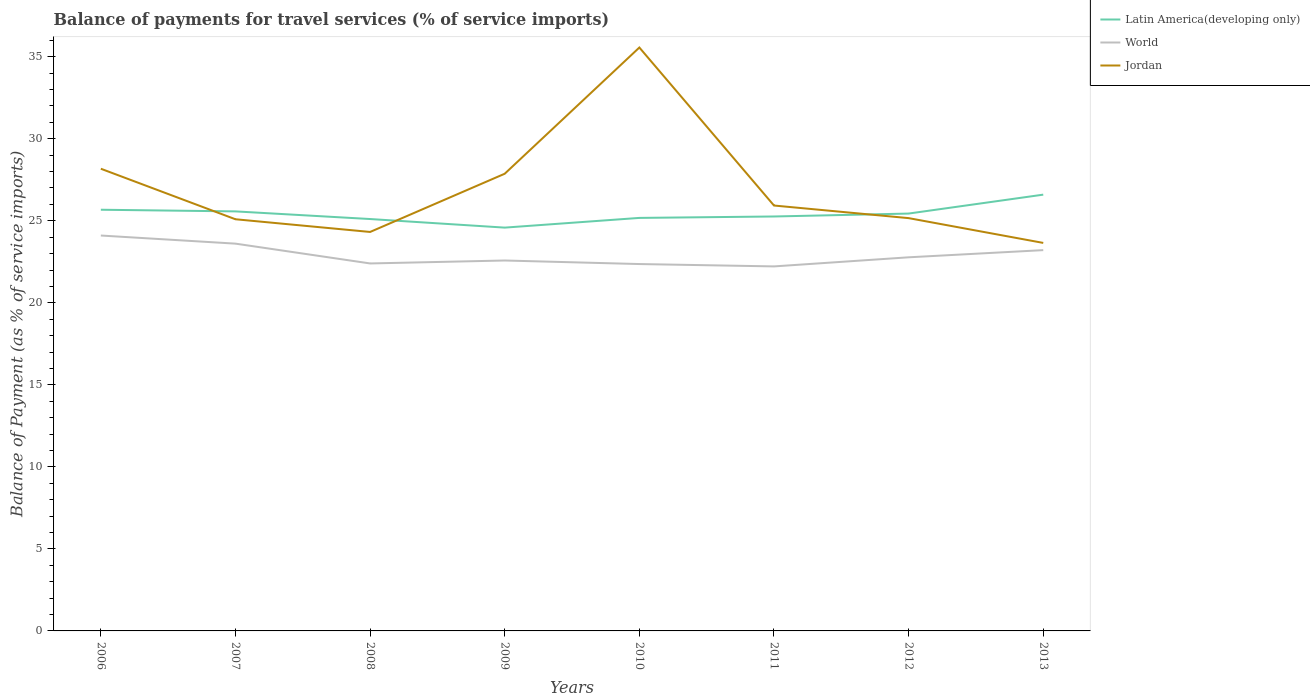How many different coloured lines are there?
Offer a terse response. 3. Across all years, what is the maximum balance of payments for travel services in Jordan?
Make the answer very short. 23.65. What is the total balance of payments for travel services in Jordan in the graph?
Ensure brevity in your answer.  2.28. What is the difference between the highest and the second highest balance of payments for travel services in Jordan?
Your response must be concise. 11.91. Is the balance of payments for travel services in World strictly greater than the balance of payments for travel services in Jordan over the years?
Provide a short and direct response. Yes. How many lines are there?
Provide a succinct answer. 3. What is the difference between two consecutive major ticks on the Y-axis?
Provide a short and direct response. 5. Does the graph contain any zero values?
Provide a short and direct response. No. Does the graph contain grids?
Your answer should be very brief. No. How are the legend labels stacked?
Give a very brief answer. Vertical. What is the title of the graph?
Provide a short and direct response. Balance of payments for travel services (% of service imports). What is the label or title of the X-axis?
Ensure brevity in your answer.  Years. What is the label or title of the Y-axis?
Offer a very short reply. Balance of Payment (as % of service imports). What is the Balance of Payment (as % of service imports) of Latin America(developing only) in 2006?
Keep it short and to the point. 25.68. What is the Balance of Payment (as % of service imports) of World in 2006?
Your response must be concise. 24.1. What is the Balance of Payment (as % of service imports) in Jordan in 2006?
Offer a very short reply. 28.17. What is the Balance of Payment (as % of service imports) in Latin America(developing only) in 2007?
Keep it short and to the point. 25.57. What is the Balance of Payment (as % of service imports) of World in 2007?
Provide a succinct answer. 23.61. What is the Balance of Payment (as % of service imports) in Jordan in 2007?
Offer a very short reply. 25.09. What is the Balance of Payment (as % of service imports) of Latin America(developing only) in 2008?
Your answer should be compact. 25.11. What is the Balance of Payment (as % of service imports) in World in 2008?
Your answer should be compact. 22.4. What is the Balance of Payment (as % of service imports) in Jordan in 2008?
Your answer should be very brief. 24.32. What is the Balance of Payment (as % of service imports) of Latin America(developing only) in 2009?
Offer a terse response. 24.58. What is the Balance of Payment (as % of service imports) of World in 2009?
Give a very brief answer. 22.58. What is the Balance of Payment (as % of service imports) of Jordan in 2009?
Offer a very short reply. 27.87. What is the Balance of Payment (as % of service imports) in Latin America(developing only) in 2010?
Provide a short and direct response. 25.18. What is the Balance of Payment (as % of service imports) of World in 2010?
Keep it short and to the point. 22.36. What is the Balance of Payment (as % of service imports) in Jordan in 2010?
Your answer should be compact. 35.56. What is the Balance of Payment (as % of service imports) of Latin America(developing only) in 2011?
Offer a very short reply. 25.26. What is the Balance of Payment (as % of service imports) in World in 2011?
Your response must be concise. 22.22. What is the Balance of Payment (as % of service imports) of Jordan in 2011?
Your answer should be very brief. 25.93. What is the Balance of Payment (as % of service imports) of Latin America(developing only) in 2012?
Offer a terse response. 25.44. What is the Balance of Payment (as % of service imports) in World in 2012?
Provide a succinct answer. 22.78. What is the Balance of Payment (as % of service imports) in Jordan in 2012?
Give a very brief answer. 25.16. What is the Balance of Payment (as % of service imports) of Latin America(developing only) in 2013?
Make the answer very short. 26.59. What is the Balance of Payment (as % of service imports) of World in 2013?
Keep it short and to the point. 23.21. What is the Balance of Payment (as % of service imports) of Jordan in 2013?
Make the answer very short. 23.65. Across all years, what is the maximum Balance of Payment (as % of service imports) of Latin America(developing only)?
Offer a very short reply. 26.59. Across all years, what is the maximum Balance of Payment (as % of service imports) of World?
Ensure brevity in your answer.  24.1. Across all years, what is the maximum Balance of Payment (as % of service imports) in Jordan?
Your answer should be compact. 35.56. Across all years, what is the minimum Balance of Payment (as % of service imports) in Latin America(developing only)?
Your answer should be compact. 24.58. Across all years, what is the minimum Balance of Payment (as % of service imports) of World?
Keep it short and to the point. 22.22. Across all years, what is the minimum Balance of Payment (as % of service imports) in Jordan?
Your answer should be compact. 23.65. What is the total Balance of Payment (as % of service imports) of Latin America(developing only) in the graph?
Offer a very short reply. 203.42. What is the total Balance of Payment (as % of service imports) of World in the graph?
Your answer should be very brief. 183.26. What is the total Balance of Payment (as % of service imports) of Jordan in the graph?
Make the answer very short. 215.77. What is the difference between the Balance of Payment (as % of service imports) of Latin America(developing only) in 2006 and that in 2007?
Your answer should be very brief. 0.1. What is the difference between the Balance of Payment (as % of service imports) in World in 2006 and that in 2007?
Offer a very short reply. 0.49. What is the difference between the Balance of Payment (as % of service imports) in Jordan in 2006 and that in 2007?
Keep it short and to the point. 3.08. What is the difference between the Balance of Payment (as % of service imports) of Latin America(developing only) in 2006 and that in 2008?
Make the answer very short. 0.57. What is the difference between the Balance of Payment (as % of service imports) of World in 2006 and that in 2008?
Give a very brief answer. 1.7. What is the difference between the Balance of Payment (as % of service imports) of Jordan in 2006 and that in 2008?
Give a very brief answer. 3.85. What is the difference between the Balance of Payment (as % of service imports) of Latin America(developing only) in 2006 and that in 2009?
Ensure brevity in your answer.  1.09. What is the difference between the Balance of Payment (as % of service imports) in World in 2006 and that in 2009?
Offer a terse response. 1.52. What is the difference between the Balance of Payment (as % of service imports) in Jordan in 2006 and that in 2009?
Provide a short and direct response. 0.3. What is the difference between the Balance of Payment (as % of service imports) in Latin America(developing only) in 2006 and that in 2010?
Keep it short and to the point. 0.5. What is the difference between the Balance of Payment (as % of service imports) of World in 2006 and that in 2010?
Offer a very short reply. 1.74. What is the difference between the Balance of Payment (as % of service imports) of Jordan in 2006 and that in 2010?
Your response must be concise. -7.39. What is the difference between the Balance of Payment (as % of service imports) of Latin America(developing only) in 2006 and that in 2011?
Offer a very short reply. 0.41. What is the difference between the Balance of Payment (as % of service imports) of World in 2006 and that in 2011?
Give a very brief answer. 1.88. What is the difference between the Balance of Payment (as % of service imports) in Jordan in 2006 and that in 2011?
Offer a terse response. 2.24. What is the difference between the Balance of Payment (as % of service imports) of Latin America(developing only) in 2006 and that in 2012?
Offer a very short reply. 0.23. What is the difference between the Balance of Payment (as % of service imports) of World in 2006 and that in 2012?
Keep it short and to the point. 1.33. What is the difference between the Balance of Payment (as % of service imports) in Jordan in 2006 and that in 2012?
Your answer should be very brief. 3.01. What is the difference between the Balance of Payment (as % of service imports) in Latin America(developing only) in 2006 and that in 2013?
Make the answer very short. -0.92. What is the difference between the Balance of Payment (as % of service imports) of World in 2006 and that in 2013?
Give a very brief answer. 0.89. What is the difference between the Balance of Payment (as % of service imports) in Jordan in 2006 and that in 2013?
Provide a short and direct response. 4.52. What is the difference between the Balance of Payment (as % of service imports) in Latin America(developing only) in 2007 and that in 2008?
Make the answer very short. 0.47. What is the difference between the Balance of Payment (as % of service imports) in World in 2007 and that in 2008?
Your response must be concise. 1.21. What is the difference between the Balance of Payment (as % of service imports) in Jordan in 2007 and that in 2008?
Provide a short and direct response. 0.77. What is the difference between the Balance of Payment (as % of service imports) of Latin America(developing only) in 2007 and that in 2009?
Provide a succinct answer. 0.99. What is the difference between the Balance of Payment (as % of service imports) in World in 2007 and that in 2009?
Provide a short and direct response. 1.03. What is the difference between the Balance of Payment (as % of service imports) of Jordan in 2007 and that in 2009?
Make the answer very short. -2.78. What is the difference between the Balance of Payment (as % of service imports) in Latin America(developing only) in 2007 and that in 2010?
Offer a terse response. 0.4. What is the difference between the Balance of Payment (as % of service imports) of World in 2007 and that in 2010?
Your response must be concise. 1.24. What is the difference between the Balance of Payment (as % of service imports) in Jordan in 2007 and that in 2010?
Ensure brevity in your answer.  -10.47. What is the difference between the Balance of Payment (as % of service imports) in Latin America(developing only) in 2007 and that in 2011?
Your answer should be compact. 0.31. What is the difference between the Balance of Payment (as % of service imports) in World in 2007 and that in 2011?
Provide a succinct answer. 1.39. What is the difference between the Balance of Payment (as % of service imports) in Jordan in 2007 and that in 2011?
Make the answer very short. -0.84. What is the difference between the Balance of Payment (as % of service imports) in Latin America(developing only) in 2007 and that in 2012?
Your answer should be compact. 0.13. What is the difference between the Balance of Payment (as % of service imports) in World in 2007 and that in 2012?
Keep it short and to the point. 0.83. What is the difference between the Balance of Payment (as % of service imports) in Jordan in 2007 and that in 2012?
Provide a succinct answer. -0.07. What is the difference between the Balance of Payment (as % of service imports) in Latin America(developing only) in 2007 and that in 2013?
Your answer should be compact. -1.02. What is the difference between the Balance of Payment (as % of service imports) of World in 2007 and that in 2013?
Provide a succinct answer. 0.4. What is the difference between the Balance of Payment (as % of service imports) in Jordan in 2007 and that in 2013?
Provide a succinct answer. 1.44. What is the difference between the Balance of Payment (as % of service imports) in Latin America(developing only) in 2008 and that in 2009?
Your response must be concise. 0.52. What is the difference between the Balance of Payment (as % of service imports) of World in 2008 and that in 2009?
Your response must be concise. -0.18. What is the difference between the Balance of Payment (as % of service imports) of Jordan in 2008 and that in 2009?
Keep it short and to the point. -3.55. What is the difference between the Balance of Payment (as % of service imports) in Latin America(developing only) in 2008 and that in 2010?
Make the answer very short. -0.07. What is the difference between the Balance of Payment (as % of service imports) in World in 2008 and that in 2010?
Your answer should be very brief. 0.04. What is the difference between the Balance of Payment (as % of service imports) of Jordan in 2008 and that in 2010?
Ensure brevity in your answer.  -11.24. What is the difference between the Balance of Payment (as % of service imports) of Latin America(developing only) in 2008 and that in 2011?
Provide a succinct answer. -0.16. What is the difference between the Balance of Payment (as % of service imports) of World in 2008 and that in 2011?
Your response must be concise. 0.18. What is the difference between the Balance of Payment (as % of service imports) in Jordan in 2008 and that in 2011?
Your response must be concise. -1.61. What is the difference between the Balance of Payment (as % of service imports) in Latin America(developing only) in 2008 and that in 2012?
Your answer should be compact. -0.33. What is the difference between the Balance of Payment (as % of service imports) in World in 2008 and that in 2012?
Your answer should be compact. -0.37. What is the difference between the Balance of Payment (as % of service imports) of Jordan in 2008 and that in 2012?
Keep it short and to the point. -0.84. What is the difference between the Balance of Payment (as % of service imports) of Latin America(developing only) in 2008 and that in 2013?
Provide a short and direct response. -1.49. What is the difference between the Balance of Payment (as % of service imports) of World in 2008 and that in 2013?
Keep it short and to the point. -0.81. What is the difference between the Balance of Payment (as % of service imports) of Jordan in 2008 and that in 2013?
Your response must be concise. 0.67. What is the difference between the Balance of Payment (as % of service imports) of Latin America(developing only) in 2009 and that in 2010?
Your response must be concise. -0.59. What is the difference between the Balance of Payment (as % of service imports) in World in 2009 and that in 2010?
Your answer should be very brief. 0.22. What is the difference between the Balance of Payment (as % of service imports) in Jordan in 2009 and that in 2010?
Your response must be concise. -7.69. What is the difference between the Balance of Payment (as % of service imports) in Latin America(developing only) in 2009 and that in 2011?
Make the answer very short. -0.68. What is the difference between the Balance of Payment (as % of service imports) in World in 2009 and that in 2011?
Your answer should be very brief. 0.36. What is the difference between the Balance of Payment (as % of service imports) in Jordan in 2009 and that in 2011?
Provide a short and direct response. 1.94. What is the difference between the Balance of Payment (as % of service imports) of Latin America(developing only) in 2009 and that in 2012?
Your answer should be very brief. -0.86. What is the difference between the Balance of Payment (as % of service imports) of World in 2009 and that in 2012?
Offer a very short reply. -0.19. What is the difference between the Balance of Payment (as % of service imports) in Jordan in 2009 and that in 2012?
Offer a terse response. 2.71. What is the difference between the Balance of Payment (as % of service imports) of Latin America(developing only) in 2009 and that in 2013?
Give a very brief answer. -2.01. What is the difference between the Balance of Payment (as % of service imports) in World in 2009 and that in 2013?
Your answer should be very brief. -0.63. What is the difference between the Balance of Payment (as % of service imports) of Jordan in 2009 and that in 2013?
Ensure brevity in your answer.  4.22. What is the difference between the Balance of Payment (as % of service imports) of Latin America(developing only) in 2010 and that in 2011?
Make the answer very short. -0.09. What is the difference between the Balance of Payment (as % of service imports) of World in 2010 and that in 2011?
Your answer should be compact. 0.14. What is the difference between the Balance of Payment (as % of service imports) in Jordan in 2010 and that in 2011?
Provide a short and direct response. 9.63. What is the difference between the Balance of Payment (as % of service imports) of Latin America(developing only) in 2010 and that in 2012?
Your answer should be compact. -0.26. What is the difference between the Balance of Payment (as % of service imports) of World in 2010 and that in 2012?
Your response must be concise. -0.41. What is the difference between the Balance of Payment (as % of service imports) in Jordan in 2010 and that in 2012?
Your answer should be very brief. 10.4. What is the difference between the Balance of Payment (as % of service imports) of Latin America(developing only) in 2010 and that in 2013?
Offer a terse response. -1.42. What is the difference between the Balance of Payment (as % of service imports) in World in 2010 and that in 2013?
Offer a very short reply. -0.85. What is the difference between the Balance of Payment (as % of service imports) in Jordan in 2010 and that in 2013?
Give a very brief answer. 11.91. What is the difference between the Balance of Payment (as % of service imports) in Latin America(developing only) in 2011 and that in 2012?
Provide a succinct answer. -0.18. What is the difference between the Balance of Payment (as % of service imports) in World in 2011 and that in 2012?
Your answer should be compact. -0.55. What is the difference between the Balance of Payment (as % of service imports) in Jordan in 2011 and that in 2012?
Provide a short and direct response. 0.77. What is the difference between the Balance of Payment (as % of service imports) in Latin America(developing only) in 2011 and that in 2013?
Your response must be concise. -1.33. What is the difference between the Balance of Payment (as % of service imports) of World in 2011 and that in 2013?
Your response must be concise. -0.99. What is the difference between the Balance of Payment (as % of service imports) in Jordan in 2011 and that in 2013?
Provide a succinct answer. 2.28. What is the difference between the Balance of Payment (as % of service imports) in Latin America(developing only) in 2012 and that in 2013?
Make the answer very short. -1.15. What is the difference between the Balance of Payment (as % of service imports) in World in 2012 and that in 2013?
Provide a succinct answer. -0.44. What is the difference between the Balance of Payment (as % of service imports) of Jordan in 2012 and that in 2013?
Provide a short and direct response. 1.51. What is the difference between the Balance of Payment (as % of service imports) of Latin America(developing only) in 2006 and the Balance of Payment (as % of service imports) of World in 2007?
Provide a short and direct response. 2.07. What is the difference between the Balance of Payment (as % of service imports) of Latin America(developing only) in 2006 and the Balance of Payment (as % of service imports) of Jordan in 2007?
Your answer should be compact. 0.58. What is the difference between the Balance of Payment (as % of service imports) in World in 2006 and the Balance of Payment (as % of service imports) in Jordan in 2007?
Ensure brevity in your answer.  -0.99. What is the difference between the Balance of Payment (as % of service imports) of Latin America(developing only) in 2006 and the Balance of Payment (as % of service imports) of World in 2008?
Provide a short and direct response. 3.27. What is the difference between the Balance of Payment (as % of service imports) in Latin America(developing only) in 2006 and the Balance of Payment (as % of service imports) in Jordan in 2008?
Your response must be concise. 1.35. What is the difference between the Balance of Payment (as % of service imports) in World in 2006 and the Balance of Payment (as % of service imports) in Jordan in 2008?
Your answer should be very brief. -0.22. What is the difference between the Balance of Payment (as % of service imports) in Latin America(developing only) in 2006 and the Balance of Payment (as % of service imports) in World in 2009?
Keep it short and to the point. 3.09. What is the difference between the Balance of Payment (as % of service imports) of Latin America(developing only) in 2006 and the Balance of Payment (as % of service imports) of Jordan in 2009?
Your answer should be very brief. -2.19. What is the difference between the Balance of Payment (as % of service imports) in World in 2006 and the Balance of Payment (as % of service imports) in Jordan in 2009?
Your response must be concise. -3.77. What is the difference between the Balance of Payment (as % of service imports) in Latin America(developing only) in 2006 and the Balance of Payment (as % of service imports) in World in 2010?
Your answer should be very brief. 3.31. What is the difference between the Balance of Payment (as % of service imports) in Latin America(developing only) in 2006 and the Balance of Payment (as % of service imports) in Jordan in 2010?
Give a very brief answer. -9.89. What is the difference between the Balance of Payment (as % of service imports) of World in 2006 and the Balance of Payment (as % of service imports) of Jordan in 2010?
Your answer should be compact. -11.46. What is the difference between the Balance of Payment (as % of service imports) of Latin America(developing only) in 2006 and the Balance of Payment (as % of service imports) of World in 2011?
Your answer should be compact. 3.45. What is the difference between the Balance of Payment (as % of service imports) of Latin America(developing only) in 2006 and the Balance of Payment (as % of service imports) of Jordan in 2011?
Make the answer very short. -0.26. What is the difference between the Balance of Payment (as % of service imports) in World in 2006 and the Balance of Payment (as % of service imports) in Jordan in 2011?
Your answer should be compact. -1.83. What is the difference between the Balance of Payment (as % of service imports) of Latin America(developing only) in 2006 and the Balance of Payment (as % of service imports) of Jordan in 2012?
Give a very brief answer. 0.51. What is the difference between the Balance of Payment (as % of service imports) of World in 2006 and the Balance of Payment (as % of service imports) of Jordan in 2012?
Ensure brevity in your answer.  -1.06. What is the difference between the Balance of Payment (as % of service imports) of Latin America(developing only) in 2006 and the Balance of Payment (as % of service imports) of World in 2013?
Give a very brief answer. 2.46. What is the difference between the Balance of Payment (as % of service imports) in Latin America(developing only) in 2006 and the Balance of Payment (as % of service imports) in Jordan in 2013?
Your answer should be compact. 2.02. What is the difference between the Balance of Payment (as % of service imports) in World in 2006 and the Balance of Payment (as % of service imports) in Jordan in 2013?
Ensure brevity in your answer.  0.45. What is the difference between the Balance of Payment (as % of service imports) of Latin America(developing only) in 2007 and the Balance of Payment (as % of service imports) of World in 2008?
Your answer should be compact. 3.17. What is the difference between the Balance of Payment (as % of service imports) of Latin America(developing only) in 2007 and the Balance of Payment (as % of service imports) of Jordan in 2008?
Your answer should be very brief. 1.25. What is the difference between the Balance of Payment (as % of service imports) of World in 2007 and the Balance of Payment (as % of service imports) of Jordan in 2008?
Provide a succinct answer. -0.71. What is the difference between the Balance of Payment (as % of service imports) in Latin America(developing only) in 2007 and the Balance of Payment (as % of service imports) in World in 2009?
Give a very brief answer. 2.99. What is the difference between the Balance of Payment (as % of service imports) of Latin America(developing only) in 2007 and the Balance of Payment (as % of service imports) of Jordan in 2009?
Give a very brief answer. -2.3. What is the difference between the Balance of Payment (as % of service imports) of World in 2007 and the Balance of Payment (as % of service imports) of Jordan in 2009?
Your answer should be very brief. -4.26. What is the difference between the Balance of Payment (as % of service imports) of Latin America(developing only) in 2007 and the Balance of Payment (as % of service imports) of World in 2010?
Your response must be concise. 3.21. What is the difference between the Balance of Payment (as % of service imports) in Latin America(developing only) in 2007 and the Balance of Payment (as % of service imports) in Jordan in 2010?
Your response must be concise. -9.99. What is the difference between the Balance of Payment (as % of service imports) of World in 2007 and the Balance of Payment (as % of service imports) of Jordan in 2010?
Give a very brief answer. -11.96. What is the difference between the Balance of Payment (as % of service imports) in Latin America(developing only) in 2007 and the Balance of Payment (as % of service imports) in World in 2011?
Make the answer very short. 3.35. What is the difference between the Balance of Payment (as % of service imports) of Latin America(developing only) in 2007 and the Balance of Payment (as % of service imports) of Jordan in 2011?
Ensure brevity in your answer.  -0.36. What is the difference between the Balance of Payment (as % of service imports) of World in 2007 and the Balance of Payment (as % of service imports) of Jordan in 2011?
Ensure brevity in your answer.  -2.32. What is the difference between the Balance of Payment (as % of service imports) of Latin America(developing only) in 2007 and the Balance of Payment (as % of service imports) of World in 2012?
Offer a very short reply. 2.8. What is the difference between the Balance of Payment (as % of service imports) in Latin America(developing only) in 2007 and the Balance of Payment (as % of service imports) in Jordan in 2012?
Your response must be concise. 0.41. What is the difference between the Balance of Payment (as % of service imports) of World in 2007 and the Balance of Payment (as % of service imports) of Jordan in 2012?
Ensure brevity in your answer.  -1.56. What is the difference between the Balance of Payment (as % of service imports) of Latin America(developing only) in 2007 and the Balance of Payment (as % of service imports) of World in 2013?
Provide a short and direct response. 2.36. What is the difference between the Balance of Payment (as % of service imports) in Latin America(developing only) in 2007 and the Balance of Payment (as % of service imports) in Jordan in 2013?
Give a very brief answer. 1.92. What is the difference between the Balance of Payment (as % of service imports) in World in 2007 and the Balance of Payment (as % of service imports) in Jordan in 2013?
Ensure brevity in your answer.  -0.04. What is the difference between the Balance of Payment (as % of service imports) in Latin America(developing only) in 2008 and the Balance of Payment (as % of service imports) in World in 2009?
Provide a short and direct response. 2.53. What is the difference between the Balance of Payment (as % of service imports) of Latin America(developing only) in 2008 and the Balance of Payment (as % of service imports) of Jordan in 2009?
Keep it short and to the point. -2.76. What is the difference between the Balance of Payment (as % of service imports) in World in 2008 and the Balance of Payment (as % of service imports) in Jordan in 2009?
Your answer should be compact. -5.47. What is the difference between the Balance of Payment (as % of service imports) in Latin America(developing only) in 2008 and the Balance of Payment (as % of service imports) in World in 2010?
Your answer should be very brief. 2.74. What is the difference between the Balance of Payment (as % of service imports) of Latin America(developing only) in 2008 and the Balance of Payment (as % of service imports) of Jordan in 2010?
Provide a short and direct response. -10.46. What is the difference between the Balance of Payment (as % of service imports) of World in 2008 and the Balance of Payment (as % of service imports) of Jordan in 2010?
Offer a terse response. -13.16. What is the difference between the Balance of Payment (as % of service imports) of Latin America(developing only) in 2008 and the Balance of Payment (as % of service imports) of World in 2011?
Give a very brief answer. 2.89. What is the difference between the Balance of Payment (as % of service imports) in Latin America(developing only) in 2008 and the Balance of Payment (as % of service imports) in Jordan in 2011?
Your answer should be compact. -0.82. What is the difference between the Balance of Payment (as % of service imports) in World in 2008 and the Balance of Payment (as % of service imports) in Jordan in 2011?
Offer a very short reply. -3.53. What is the difference between the Balance of Payment (as % of service imports) of Latin America(developing only) in 2008 and the Balance of Payment (as % of service imports) of World in 2012?
Provide a succinct answer. 2.33. What is the difference between the Balance of Payment (as % of service imports) of Latin America(developing only) in 2008 and the Balance of Payment (as % of service imports) of Jordan in 2012?
Offer a very short reply. -0.06. What is the difference between the Balance of Payment (as % of service imports) in World in 2008 and the Balance of Payment (as % of service imports) in Jordan in 2012?
Make the answer very short. -2.76. What is the difference between the Balance of Payment (as % of service imports) in Latin America(developing only) in 2008 and the Balance of Payment (as % of service imports) in World in 2013?
Provide a short and direct response. 1.9. What is the difference between the Balance of Payment (as % of service imports) in Latin America(developing only) in 2008 and the Balance of Payment (as % of service imports) in Jordan in 2013?
Offer a very short reply. 1.46. What is the difference between the Balance of Payment (as % of service imports) of World in 2008 and the Balance of Payment (as % of service imports) of Jordan in 2013?
Offer a very short reply. -1.25. What is the difference between the Balance of Payment (as % of service imports) of Latin America(developing only) in 2009 and the Balance of Payment (as % of service imports) of World in 2010?
Make the answer very short. 2.22. What is the difference between the Balance of Payment (as % of service imports) in Latin America(developing only) in 2009 and the Balance of Payment (as % of service imports) in Jordan in 2010?
Your response must be concise. -10.98. What is the difference between the Balance of Payment (as % of service imports) of World in 2009 and the Balance of Payment (as % of service imports) of Jordan in 2010?
Your answer should be very brief. -12.98. What is the difference between the Balance of Payment (as % of service imports) of Latin America(developing only) in 2009 and the Balance of Payment (as % of service imports) of World in 2011?
Keep it short and to the point. 2.36. What is the difference between the Balance of Payment (as % of service imports) in Latin America(developing only) in 2009 and the Balance of Payment (as % of service imports) in Jordan in 2011?
Your response must be concise. -1.35. What is the difference between the Balance of Payment (as % of service imports) in World in 2009 and the Balance of Payment (as % of service imports) in Jordan in 2011?
Your response must be concise. -3.35. What is the difference between the Balance of Payment (as % of service imports) of Latin America(developing only) in 2009 and the Balance of Payment (as % of service imports) of World in 2012?
Provide a succinct answer. 1.81. What is the difference between the Balance of Payment (as % of service imports) of Latin America(developing only) in 2009 and the Balance of Payment (as % of service imports) of Jordan in 2012?
Give a very brief answer. -0.58. What is the difference between the Balance of Payment (as % of service imports) of World in 2009 and the Balance of Payment (as % of service imports) of Jordan in 2012?
Ensure brevity in your answer.  -2.58. What is the difference between the Balance of Payment (as % of service imports) in Latin America(developing only) in 2009 and the Balance of Payment (as % of service imports) in World in 2013?
Your answer should be very brief. 1.37. What is the difference between the Balance of Payment (as % of service imports) of Latin America(developing only) in 2009 and the Balance of Payment (as % of service imports) of Jordan in 2013?
Provide a succinct answer. 0.93. What is the difference between the Balance of Payment (as % of service imports) in World in 2009 and the Balance of Payment (as % of service imports) in Jordan in 2013?
Offer a terse response. -1.07. What is the difference between the Balance of Payment (as % of service imports) in Latin America(developing only) in 2010 and the Balance of Payment (as % of service imports) in World in 2011?
Give a very brief answer. 2.96. What is the difference between the Balance of Payment (as % of service imports) of Latin America(developing only) in 2010 and the Balance of Payment (as % of service imports) of Jordan in 2011?
Make the answer very short. -0.75. What is the difference between the Balance of Payment (as % of service imports) in World in 2010 and the Balance of Payment (as % of service imports) in Jordan in 2011?
Your answer should be very brief. -3.57. What is the difference between the Balance of Payment (as % of service imports) in Latin America(developing only) in 2010 and the Balance of Payment (as % of service imports) in World in 2012?
Your response must be concise. 2.4. What is the difference between the Balance of Payment (as % of service imports) in Latin America(developing only) in 2010 and the Balance of Payment (as % of service imports) in Jordan in 2012?
Provide a succinct answer. 0.01. What is the difference between the Balance of Payment (as % of service imports) of World in 2010 and the Balance of Payment (as % of service imports) of Jordan in 2012?
Your response must be concise. -2.8. What is the difference between the Balance of Payment (as % of service imports) of Latin America(developing only) in 2010 and the Balance of Payment (as % of service imports) of World in 2013?
Make the answer very short. 1.96. What is the difference between the Balance of Payment (as % of service imports) of Latin America(developing only) in 2010 and the Balance of Payment (as % of service imports) of Jordan in 2013?
Offer a very short reply. 1.52. What is the difference between the Balance of Payment (as % of service imports) of World in 2010 and the Balance of Payment (as % of service imports) of Jordan in 2013?
Provide a succinct answer. -1.29. What is the difference between the Balance of Payment (as % of service imports) of Latin America(developing only) in 2011 and the Balance of Payment (as % of service imports) of World in 2012?
Offer a very short reply. 2.49. What is the difference between the Balance of Payment (as % of service imports) in Latin America(developing only) in 2011 and the Balance of Payment (as % of service imports) in Jordan in 2012?
Your answer should be very brief. 0.1. What is the difference between the Balance of Payment (as % of service imports) of World in 2011 and the Balance of Payment (as % of service imports) of Jordan in 2012?
Provide a short and direct response. -2.94. What is the difference between the Balance of Payment (as % of service imports) in Latin America(developing only) in 2011 and the Balance of Payment (as % of service imports) in World in 2013?
Keep it short and to the point. 2.05. What is the difference between the Balance of Payment (as % of service imports) of Latin America(developing only) in 2011 and the Balance of Payment (as % of service imports) of Jordan in 2013?
Make the answer very short. 1.61. What is the difference between the Balance of Payment (as % of service imports) in World in 2011 and the Balance of Payment (as % of service imports) in Jordan in 2013?
Offer a terse response. -1.43. What is the difference between the Balance of Payment (as % of service imports) in Latin America(developing only) in 2012 and the Balance of Payment (as % of service imports) in World in 2013?
Give a very brief answer. 2.23. What is the difference between the Balance of Payment (as % of service imports) in Latin America(developing only) in 2012 and the Balance of Payment (as % of service imports) in Jordan in 2013?
Your answer should be very brief. 1.79. What is the difference between the Balance of Payment (as % of service imports) in World in 2012 and the Balance of Payment (as % of service imports) in Jordan in 2013?
Ensure brevity in your answer.  -0.88. What is the average Balance of Payment (as % of service imports) of Latin America(developing only) per year?
Keep it short and to the point. 25.43. What is the average Balance of Payment (as % of service imports) in World per year?
Ensure brevity in your answer.  22.91. What is the average Balance of Payment (as % of service imports) of Jordan per year?
Offer a very short reply. 26.97. In the year 2006, what is the difference between the Balance of Payment (as % of service imports) of Latin America(developing only) and Balance of Payment (as % of service imports) of World?
Make the answer very short. 1.57. In the year 2006, what is the difference between the Balance of Payment (as % of service imports) in Latin America(developing only) and Balance of Payment (as % of service imports) in Jordan?
Keep it short and to the point. -2.5. In the year 2006, what is the difference between the Balance of Payment (as % of service imports) in World and Balance of Payment (as % of service imports) in Jordan?
Your answer should be compact. -4.07. In the year 2007, what is the difference between the Balance of Payment (as % of service imports) in Latin America(developing only) and Balance of Payment (as % of service imports) in World?
Your response must be concise. 1.97. In the year 2007, what is the difference between the Balance of Payment (as % of service imports) in Latin America(developing only) and Balance of Payment (as % of service imports) in Jordan?
Offer a very short reply. 0.48. In the year 2007, what is the difference between the Balance of Payment (as % of service imports) of World and Balance of Payment (as % of service imports) of Jordan?
Your answer should be very brief. -1.49. In the year 2008, what is the difference between the Balance of Payment (as % of service imports) of Latin America(developing only) and Balance of Payment (as % of service imports) of World?
Provide a succinct answer. 2.71. In the year 2008, what is the difference between the Balance of Payment (as % of service imports) in Latin America(developing only) and Balance of Payment (as % of service imports) in Jordan?
Provide a short and direct response. 0.79. In the year 2008, what is the difference between the Balance of Payment (as % of service imports) in World and Balance of Payment (as % of service imports) in Jordan?
Provide a short and direct response. -1.92. In the year 2009, what is the difference between the Balance of Payment (as % of service imports) in Latin America(developing only) and Balance of Payment (as % of service imports) in World?
Give a very brief answer. 2. In the year 2009, what is the difference between the Balance of Payment (as % of service imports) of Latin America(developing only) and Balance of Payment (as % of service imports) of Jordan?
Offer a very short reply. -3.28. In the year 2009, what is the difference between the Balance of Payment (as % of service imports) in World and Balance of Payment (as % of service imports) in Jordan?
Offer a very short reply. -5.29. In the year 2010, what is the difference between the Balance of Payment (as % of service imports) in Latin America(developing only) and Balance of Payment (as % of service imports) in World?
Keep it short and to the point. 2.81. In the year 2010, what is the difference between the Balance of Payment (as % of service imports) of Latin America(developing only) and Balance of Payment (as % of service imports) of Jordan?
Ensure brevity in your answer.  -10.39. In the year 2010, what is the difference between the Balance of Payment (as % of service imports) in World and Balance of Payment (as % of service imports) in Jordan?
Make the answer very short. -13.2. In the year 2011, what is the difference between the Balance of Payment (as % of service imports) of Latin America(developing only) and Balance of Payment (as % of service imports) of World?
Offer a terse response. 3.04. In the year 2011, what is the difference between the Balance of Payment (as % of service imports) of Latin America(developing only) and Balance of Payment (as % of service imports) of Jordan?
Give a very brief answer. -0.67. In the year 2011, what is the difference between the Balance of Payment (as % of service imports) of World and Balance of Payment (as % of service imports) of Jordan?
Your answer should be compact. -3.71. In the year 2012, what is the difference between the Balance of Payment (as % of service imports) in Latin America(developing only) and Balance of Payment (as % of service imports) in World?
Offer a terse response. 2.67. In the year 2012, what is the difference between the Balance of Payment (as % of service imports) in Latin America(developing only) and Balance of Payment (as % of service imports) in Jordan?
Offer a very short reply. 0.28. In the year 2012, what is the difference between the Balance of Payment (as % of service imports) in World and Balance of Payment (as % of service imports) in Jordan?
Your answer should be very brief. -2.39. In the year 2013, what is the difference between the Balance of Payment (as % of service imports) of Latin America(developing only) and Balance of Payment (as % of service imports) of World?
Your answer should be compact. 3.38. In the year 2013, what is the difference between the Balance of Payment (as % of service imports) in Latin America(developing only) and Balance of Payment (as % of service imports) in Jordan?
Your answer should be very brief. 2.94. In the year 2013, what is the difference between the Balance of Payment (as % of service imports) in World and Balance of Payment (as % of service imports) in Jordan?
Your answer should be very brief. -0.44. What is the ratio of the Balance of Payment (as % of service imports) in Latin America(developing only) in 2006 to that in 2007?
Provide a succinct answer. 1. What is the ratio of the Balance of Payment (as % of service imports) of World in 2006 to that in 2007?
Offer a very short reply. 1.02. What is the ratio of the Balance of Payment (as % of service imports) in Jordan in 2006 to that in 2007?
Give a very brief answer. 1.12. What is the ratio of the Balance of Payment (as % of service imports) in Latin America(developing only) in 2006 to that in 2008?
Your answer should be very brief. 1.02. What is the ratio of the Balance of Payment (as % of service imports) in World in 2006 to that in 2008?
Offer a very short reply. 1.08. What is the ratio of the Balance of Payment (as % of service imports) in Jordan in 2006 to that in 2008?
Offer a very short reply. 1.16. What is the ratio of the Balance of Payment (as % of service imports) of Latin America(developing only) in 2006 to that in 2009?
Provide a short and direct response. 1.04. What is the ratio of the Balance of Payment (as % of service imports) in World in 2006 to that in 2009?
Your answer should be very brief. 1.07. What is the ratio of the Balance of Payment (as % of service imports) of Jordan in 2006 to that in 2009?
Offer a very short reply. 1.01. What is the ratio of the Balance of Payment (as % of service imports) in Latin America(developing only) in 2006 to that in 2010?
Give a very brief answer. 1.02. What is the ratio of the Balance of Payment (as % of service imports) of World in 2006 to that in 2010?
Your answer should be compact. 1.08. What is the ratio of the Balance of Payment (as % of service imports) of Jordan in 2006 to that in 2010?
Your response must be concise. 0.79. What is the ratio of the Balance of Payment (as % of service imports) in Latin America(developing only) in 2006 to that in 2011?
Offer a terse response. 1.02. What is the ratio of the Balance of Payment (as % of service imports) in World in 2006 to that in 2011?
Ensure brevity in your answer.  1.08. What is the ratio of the Balance of Payment (as % of service imports) in Jordan in 2006 to that in 2011?
Offer a very short reply. 1.09. What is the ratio of the Balance of Payment (as % of service imports) of Latin America(developing only) in 2006 to that in 2012?
Your answer should be compact. 1.01. What is the ratio of the Balance of Payment (as % of service imports) in World in 2006 to that in 2012?
Give a very brief answer. 1.06. What is the ratio of the Balance of Payment (as % of service imports) of Jordan in 2006 to that in 2012?
Offer a very short reply. 1.12. What is the ratio of the Balance of Payment (as % of service imports) of Latin America(developing only) in 2006 to that in 2013?
Provide a succinct answer. 0.97. What is the ratio of the Balance of Payment (as % of service imports) of World in 2006 to that in 2013?
Provide a succinct answer. 1.04. What is the ratio of the Balance of Payment (as % of service imports) in Jordan in 2006 to that in 2013?
Your answer should be very brief. 1.19. What is the ratio of the Balance of Payment (as % of service imports) in Latin America(developing only) in 2007 to that in 2008?
Your response must be concise. 1.02. What is the ratio of the Balance of Payment (as % of service imports) of World in 2007 to that in 2008?
Make the answer very short. 1.05. What is the ratio of the Balance of Payment (as % of service imports) in Jordan in 2007 to that in 2008?
Keep it short and to the point. 1.03. What is the ratio of the Balance of Payment (as % of service imports) of Latin America(developing only) in 2007 to that in 2009?
Your response must be concise. 1.04. What is the ratio of the Balance of Payment (as % of service imports) of World in 2007 to that in 2009?
Make the answer very short. 1.05. What is the ratio of the Balance of Payment (as % of service imports) in Jordan in 2007 to that in 2009?
Ensure brevity in your answer.  0.9. What is the ratio of the Balance of Payment (as % of service imports) in Latin America(developing only) in 2007 to that in 2010?
Your answer should be very brief. 1.02. What is the ratio of the Balance of Payment (as % of service imports) in World in 2007 to that in 2010?
Your answer should be compact. 1.06. What is the ratio of the Balance of Payment (as % of service imports) of Jordan in 2007 to that in 2010?
Your response must be concise. 0.71. What is the ratio of the Balance of Payment (as % of service imports) in Latin America(developing only) in 2007 to that in 2011?
Your answer should be compact. 1.01. What is the ratio of the Balance of Payment (as % of service imports) in World in 2007 to that in 2011?
Offer a very short reply. 1.06. What is the ratio of the Balance of Payment (as % of service imports) of World in 2007 to that in 2012?
Ensure brevity in your answer.  1.04. What is the ratio of the Balance of Payment (as % of service imports) in Latin America(developing only) in 2007 to that in 2013?
Your response must be concise. 0.96. What is the ratio of the Balance of Payment (as % of service imports) of World in 2007 to that in 2013?
Your answer should be compact. 1.02. What is the ratio of the Balance of Payment (as % of service imports) in Jordan in 2007 to that in 2013?
Make the answer very short. 1.06. What is the ratio of the Balance of Payment (as % of service imports) in Latin America(developing only) in 2008 to that in 2009?
Your answer should be compact. 1.02. What is the ratio of the Balance of Payment (as % of service imports) of Jordan in 2008 to that in 2009?
Give a very brief answer. 0.87. What is the ratio of the Balance of Payment (as % of service imports) of Jordan in 2008 to that in 2010?
Make the answer very short. 0.68. What is the ratio of the Balance of Payment (as % of service imports) in Latin America(developing only) in 2008 to that in 2011?
Offer a very short reply. 0.99. What is the ratio of the Balance of Payment (as % of service imports) of Jordan in 2008 to that in 2011?
Your response must be concise. 0.94. What is the ratio of the Balance of Payment (as % of service imports) of Latin America(developing only) in 2008 to that in 2012?
Your response must be concise. 0.99. What is the ratio of the Balance of Payment (as % of service imports) of World in 2008 to that in 2012?
Provide a short and direct response. 0.98. What is the ratio of the Balance of Payment (as % of service imports) in Jordan in 2008 to that in 2012?
Offer a very short reply. 0.97. What is the ratio of the Balance of Payment (as % of service imports) of Latin America(developing only) in 2008 to that in 2013?
Ensure brevity in your answer.  0.94. What is the ratio of the Balance of Payment (as % of service imports) of World in 2008 to that in 2013?
Your answer should be very brief. 0.96. What is the ratio of the Balance of Payment (as % of service imports) of Jordan in 2008 to that in 2013?
Offer a terse response. 1.03. What is the ratio of the Balance of Payment (as % of service imports) in Latin America(developing only) in 2009 to that in 2010?
Offer a terse response. 0.98. What is the ratio of the Balance of Payment (as % of service imports) of World in 2009 to that in 2010?
Offer a very short reply. 1.01. What is the ratio of the Balance of Payment (as % of service imports) of Jordan in 2009 to that in 2010?
Provide a short and direct response. 0.78. What is the ratio of the Balance of Payment (as % of service imports) of Latin America(developing only) in 2009 to that in 2011?
Keep it short and to the point. 0.97. What is the ratio of the Balance of Payment (as % of service imports) in World in 2009 to that in 2011?
Make the answer very short. 1.02. What is the ratio of the Balance of Payment (as % of service imports) of Jordan in 2009 to that in 2011?
Give a very brief answer. 1.07. What is the ratio of the Balance of Payment (as % of service imports) of Latin America(developing only) in 2009 to that in 2012?
Ensure brevity in your answer.  0.97. What is the ratio of the Balance of Payment (as % of service imports) of World in 2009 to that in 2012?
Provide a succinct answer. 0.99. What is the ratio of the Balance of Payment (as % of service imports) in Jordan in 2009 to that in 2012?
Give a very brief answer. 1.11. What is the ratio of the Balance of Payment (as % of service imports) of Latin America(developing only) in 2009 to that in 2013?
Your answer should be very brief. 0.92. What is the ratio of the Balance of Payment (as % of service imports) of World in 2009 to that in 2013?
Offer a very short reply. 0.97. What is the ratio of the Balance of Payment (as % of service imports) in Jordan in 2009 to that in 2013?
Make the answer very short. 1.18. What is the ratio of the Balance of Payment (as % of service imports) in Jordan in 2010 to that in 2011?
Provide a short and direct response. 1.37. What is the ratio of the Balance of Payment (as % of service imports) of Jordan in 2010 to that in 2012?
Offer a terse response. 1.41. What is the ratio of the Balance of Payment (as % of service imports) of Latin America(developing only) in 2010 to that in 2013?
Give a very brief answer. 0.95. What is the ratio of the Balance of Payment (as % of service imports) of World in 2010 to that in 2013?
Your answer should be compact. 0.96. What is the ratio of the Balance of Payment (as % of service imports) in Jordan in 2010 to that in 2013?
Your response must be concise. 1.5. What is the ratio of the Balance of Payment (as % of service imports) in World in 2011 to that in 2012?
Offer a terse response. 0.98. What is the ratio of the Balance of Payment (as % of service imports) in Jordan in 2011 to that in 2012?
Provide a short and direct response. 1.03. What is the ratio of the Balance of Payment (as % of service imports) of World in 2011 to that in 2013?
Provide a short and direct response. 0.96. What is the ratio of the Balance of Payment (as % of service imports) of Jordan in 2011 to that in 2013?
Your answer should be very brief. 1.1. What is the ratio of the Balance of Payment (as % of service imports) of Latin America(developing only) in 2012 to that in 2013?
Your response must be concise. 0.96. What is the ratio of the Balance of Payment (as % of service imports) in World in 2012 to that in 2013?
Your response must be concise. 0.98. What is the ratio of the Balance of Payment (as % of service imports) in Jordan in 2012 to that in 2013?
Your response must be concise. 1.06. What is the difference between the highest and the second highest Balance of Payment (as % of service imports) of Latin America(developing only)?
Offer a very short reply. 0.92. What is the difference between the highest and the second highest Balance of Payment (as % of service imports) of World?
Ensure brevity in your answer.  0.49. What is the difference between the highest and the second highest Balance of Payment (as % of service imports) in Jordan?
Your response must be concise. 7.39. What is the difference between the highest and the lowest Balance of Payment (as % of service imports) of Latin America(developing only)?
Offer a terse response. 2.01. What is the difference between the highest and the lowest Balance of Payment (as % of service imports) in World?
Your answer should be compact. 1.88. What is the difference between the highest and the lowest Balance of Payment (as % of service imports) of Jordan?
Provide a succinct answer. 11.91. 